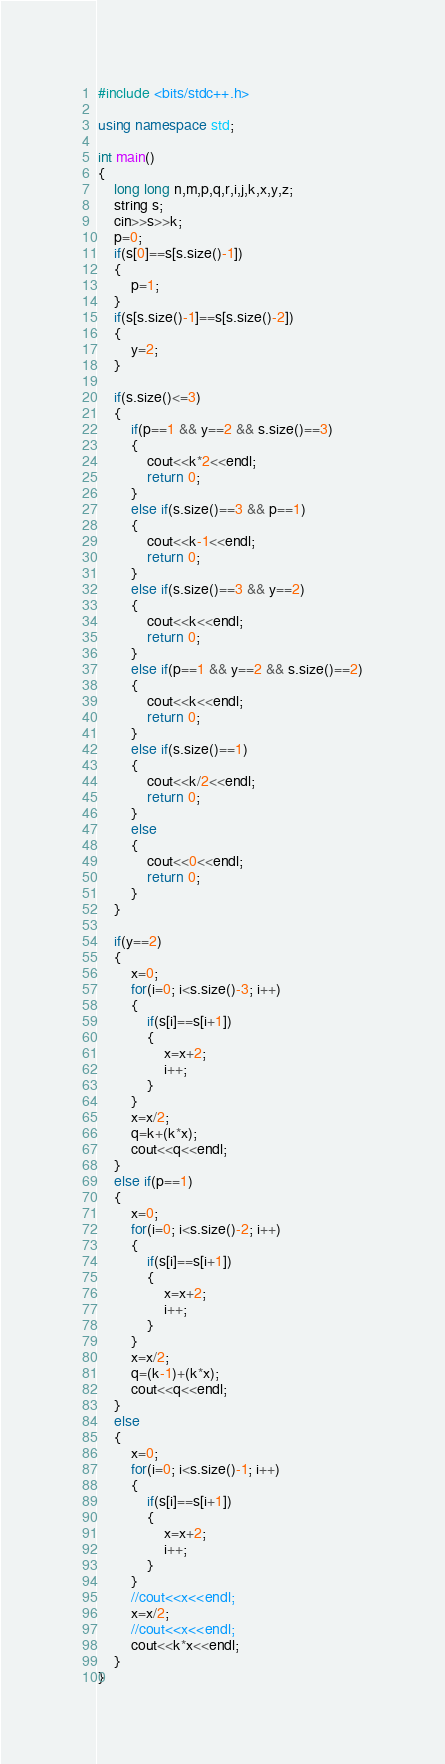<code> <loc_0><loc_0><loc_500><loc_500><_C++_>#include <bits/stdc++.h>

using namespace std;

int main()
{
    long long n,m,p,q,r,i,j,k,x,y,z;
    string s;
    cin>>s>>k;
    p=0;
    if(s[0]==s[s.size()-1])
    {
        p=1;
    }
    if(s[s.size()-1]==s[s.size()-2])
    {
        y=2;
    }

    if(s.size()<=3)
    {
        if(p==1 && y==2 && s.size()==3)
        {
            cout<<k*2<<endl;
            return 0;
        }
        else if(s.size()==3 && p==1)
        {
            cout<<k-1<<endl;
            return 0;
        }
        else if(s.size()==3 && y==2)
        {
            cout<<k<<endl;
            return 0;
        }
        else if(p==1 && y==2 && s.size()==2)
        {
            cout<<k<<endl;
            return 0;
        }
        else if(s.size()==1)
        {
            cout<<k/2<<endl;
            return 0;
        }
        else
        {
            cout<<0<<endl;
            return 0;
        }
    }

    if(y==2)
    {
        x=0;
        for(i=0; i<s.size()-3; i++)
        {
            if(s[i]==s[i+1])
            {
                x=x+2;
                i++;
            }
        }
        x=x/2;
        q=k+(k*x);
        cout<<q<<endl;
    }
    else if(p==1)
    {
        x=0;
        for(i=0; i<s.size()-2; i++)
        {
            if(s[i]==s[i+1])
            {
                x=x+2;
                i++;
            }
        }
        x=x/2;
        q=(k-1)+(k*x);
        cout<<q<<endl;
    }
    else
    {
        x=0;
        for(i=0; i<s.size()-1; i++)
        {
            if(s[i]==s[i+1])
            {
                x=x+2;
                i++;
            }
        }
        //cout<<x<<endl;
        x=x/2;
        //cout<<x<<endl;
        cout<<k*x<<endl;
    }
}
</code> 